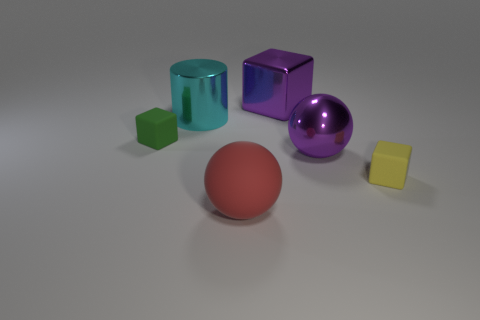There is a big ball that is behind the red matte sphere; does it have the same color as the matte object behind the yellow object?
Make the answer very short. No. How big is the green rubber thing?
Provide a short and direct response. Small. How many small objects are purple metallic cubes or shiny spheres?
Provide a short and direct response. 0. The shiny cylinder that is the same size as the purple ball is what color?
Offer a terse response. Cyan. What number of other objects are there of the same shape as the cyan metal object?
Your answer should be very brief. 0. Is there a small yellow cylinder that has the same material as the tiny green thing?
Provide a succinct answer. No. Are the object to the right of the metallic sphere and the ball that is on the right side of the large red matte sphere made of the same material?
Give a very brief answer. No. What number of tiny yellow blocks are there?
Keep it short and to the point. 1. There is a purple metallic thing on the left side of the metal ball; what is its shape?
Your response must be concise. Cube. What number of other things are the same size as the yellow block?
Offer a very short reply. 1. 